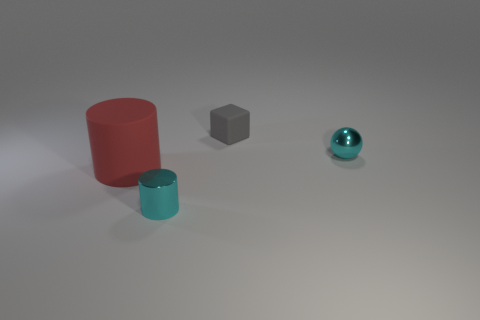Add 4 large blocks. How many objects exist? 8 Subtract all blocks. How many objects are left? 3 Add 3 small gray matte cubes. How many small gray matte cubes exist? 4 Subtract 0 brown cubes. How many objects are left? 4 Subtract all purple rubber objects. Subtract all gray rubber objects. How many objects are left? 3 Add 1 tiny shiny cylinders. How many tiny shiny cylinders are left? 2 